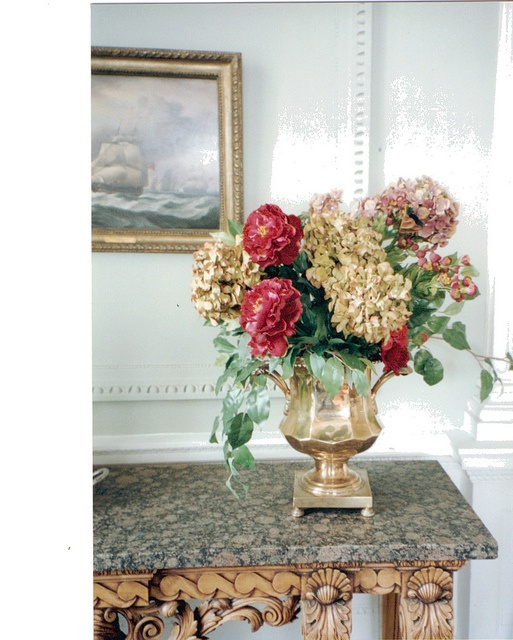Describe the objects in this image and their specific colors. I can see a vase in white, tan, and lightgray tones in this image. 